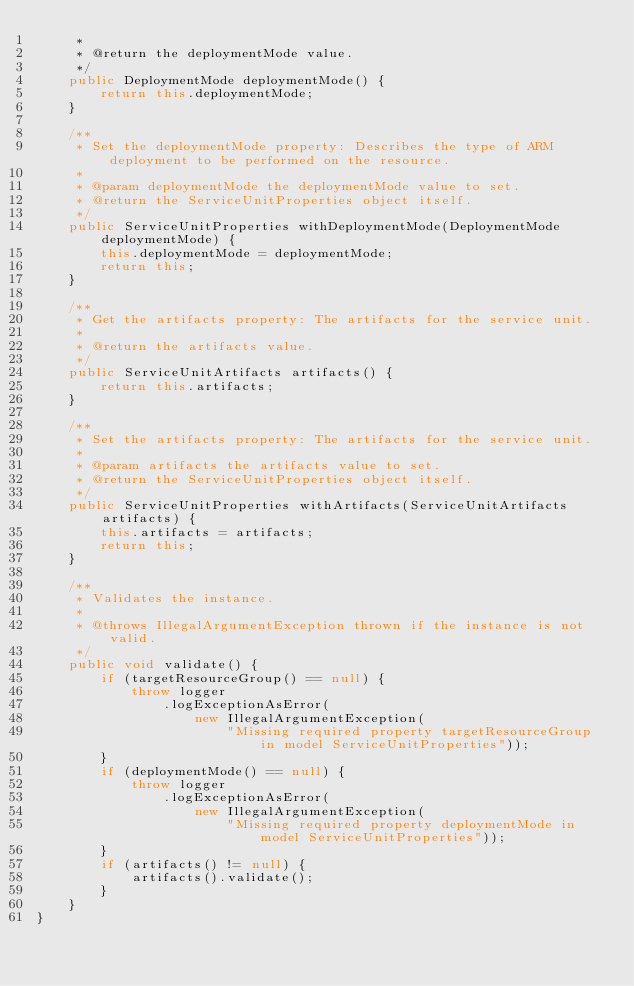<code> <loc_0><loc_0><loc_500><loc_500><_Java_>     *
     * @return the deploymentMode value.
     */
    public DeploymentMode deploymentMode() {
        return this.deploymentMode;
    }

    /**
     * Set the deploymentMode property: Describes the type of ARM deployment to be performed on the resource.
     *
     * @param deploymentMode the deploymentMode value to set.
     * @return the ServiceUnitProperties object itself.
     */
    public ServiceUnitProperties withDeploymentMode(DeploymentMode deploymentMode) {
        this.deploymentMode = deploymentMode;
        return this;
    }

    /**
     * Get the artifacts property: The artifacts for the service unit.
     *
     * @return the artifacts value.
     */
    public ServiceUnitArtifacts artifacts() {
        return this.artifacts;
    }

    /**
     * Set the artifacts property: The artifacts for the service unit.
     *
     * @param artifacts the artifacts value to set.
     * @return the ServiceUnitProperties object itself.
     */
    public ServiceUnitProperties withArtifacts(ServiceUnitArtifacts artifacts) {
        this.artifacts = artifacts;
        return this;
    }

    /**
     * Validates the instance.
     *
     * @throws IllegalArgumentException thrown if the instance is not valid.
     */
    public void validate() {
        if (targetResourceGroup() == null) {
            throw logger
                .logExceptionAsError(
                    new IllegalArgumentException(
                        "Missing required property targetResourceGroup in model ServiceUnitProperties"));
        }
        if (deploymentMode() == null) {
            throw logger
                .logExceptionAsError(
                    new IllegalArgumentException(
                        "Missing required property deploymentMode in model ServiceUnitProperties"));
        }
        if (artifacts() != null) {
            artifacts().validate();
        }
    }
}
</code> 